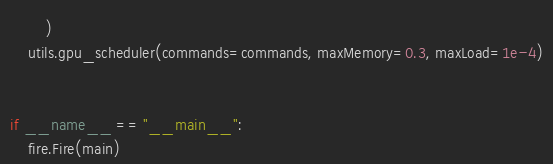Convert code to text. <code><loc_0><loc_0><loc_500><loc_500><_Python_>        )
    utils.gpu_scheduler(commands=commands, maxMemory=0.3, maxLoad=1e-4)


if __name__ == "__main__":
    fire.Fire(main)
</code> 